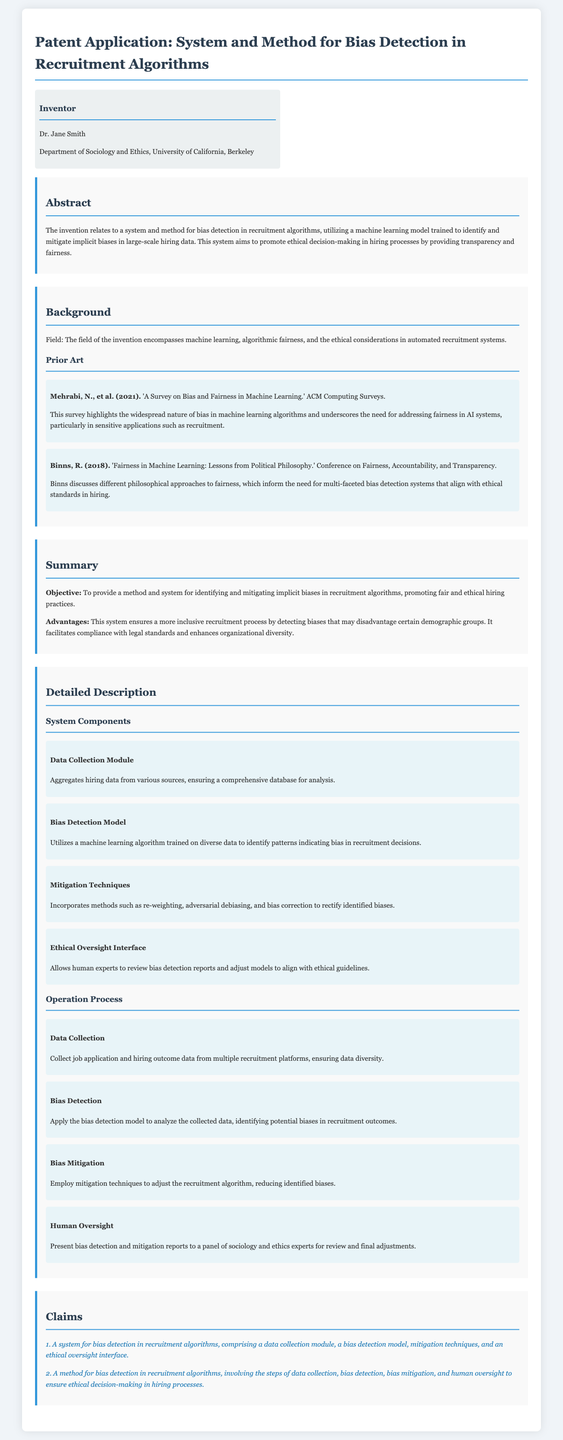What is the name of the inventor? The inventor's name is mentioned in the document as Dr. Jane Smith.
Answer: Dr. Jane Smith What is the primary objective of the invention? The primary objective is stated as identifying and mitigating implicit biases in recruitment algorithms.
Answer: Identifying and mitigating implicit biases What is the title of the patent application? The title provides a concise description of the system and method being proposed for bias detection in recruitment algorithms.
Answer: System and Method for Bias Detection in Recruitment Algorithms What machine learning technique is mentioned for bias mitigation? The methods for bias mitigation include techniques such as re-weighting, adversarial debiasing, and bias correction.
Answer: Re-weighting, adversarial debiasing, and bias correction Who conducted the survey referenced in the prior art section? The survey cited in the prior art section is conducted by Mehrabi, N., et al.
Answer: Mehrabi, N., et al What is the background field of this invention? The field encompassing the invention involves machine learning, algorithmic fairness, and ethical considerations in automated recruitment systems.
Answer: Machine learning, algorithmic fairness, and ethical considerations How many claims are listed in the document? The document explicitly states a total of two claims regarding the system and method for bias detection.
Answer: Two claims What is the function of the Ethical Oversight Interface? The Ethical Oversight Interface allows human experts to review bias detection reports and adjust models.
Answer: Review bias detection reports and adjust models What does the Bias Detection Model utilize? The Bias Detection Model utilizes a machine learning algorithm trained on diverse data to identify bias.
Answer: A machine learning algorithm trained on diverse data 